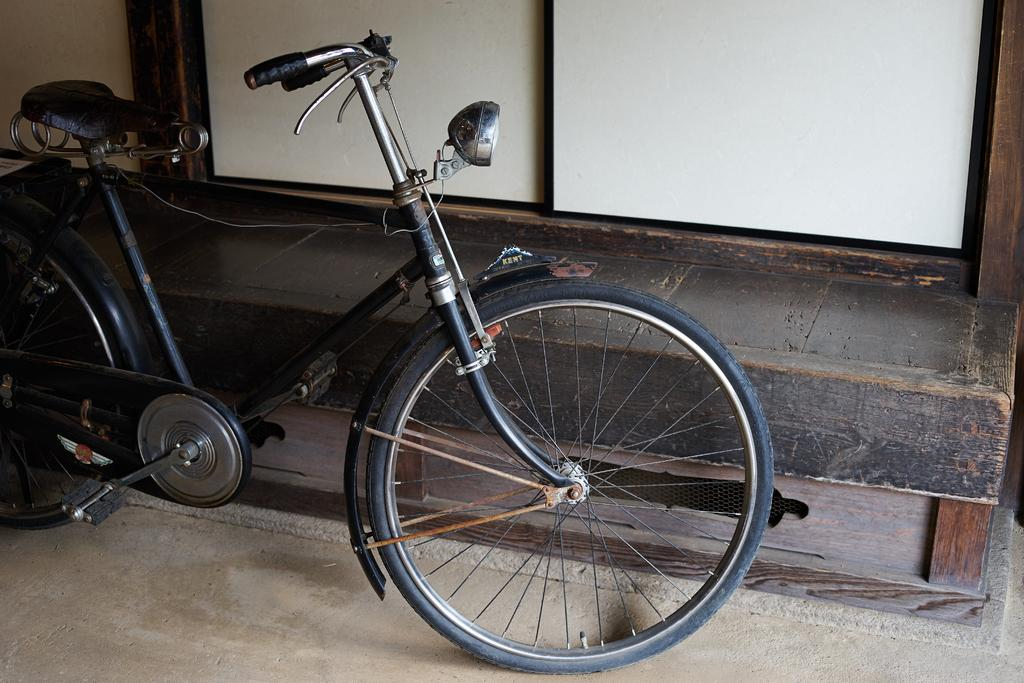What type of surface is visible in the image? There is ground visible in the image. What object is placed on the ground? There is a black bicycle on the ground. What type of door can be seen in the image? There is a white and black colored wooden door in the image. Can you hear the toad laughing in the image? There is no toad or laughter present in the image. 